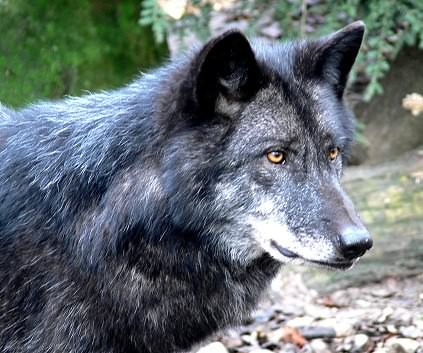What social structures do wolves typically exhibit? Wolves are known for their complex social structures, typically forming packs that are led by an alpha male and female. Packs consist of family members including offspring. This structure promotes cooperative hunting, territory defense, and rearing of the young, which enhances survival rates and stabilizes their societal framework. What are some common misconceptions about wolves? One common misconception is that wolves are frequently dangerous to humans; in reality, they are generally reclusive and avoid human contact. Another is that all wolves howl at the moon, while in truth, they howl to communicate with each other regardless of moon presence. These communications can signify territory ownership or rally the pack for hunting. 